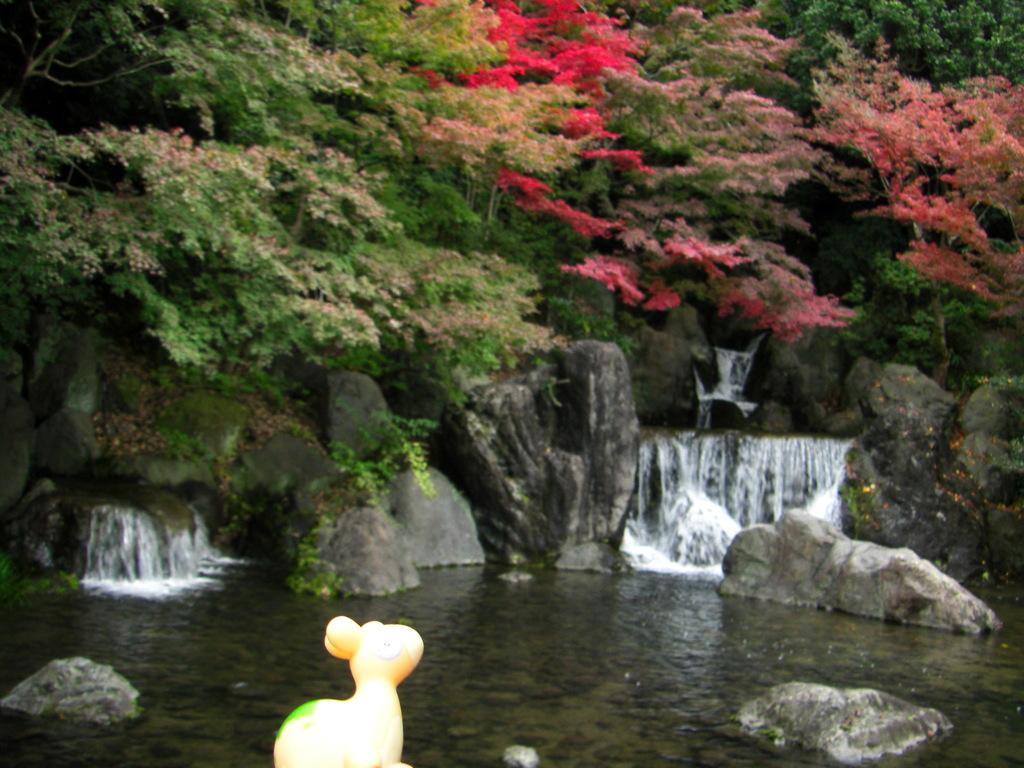What object can be seen in the image that is typically used for play? There is a toy in the image. What type of natural elements are present in the image? There are rocks and water visible in the image. What can be seen in the background of the image? There are trees in the background of the image. What type of space-themed bear can be seen interacting with the toy in the image? There is no bear or space-themed elements present in the image; it features a toy, rocks, water, and trees. 